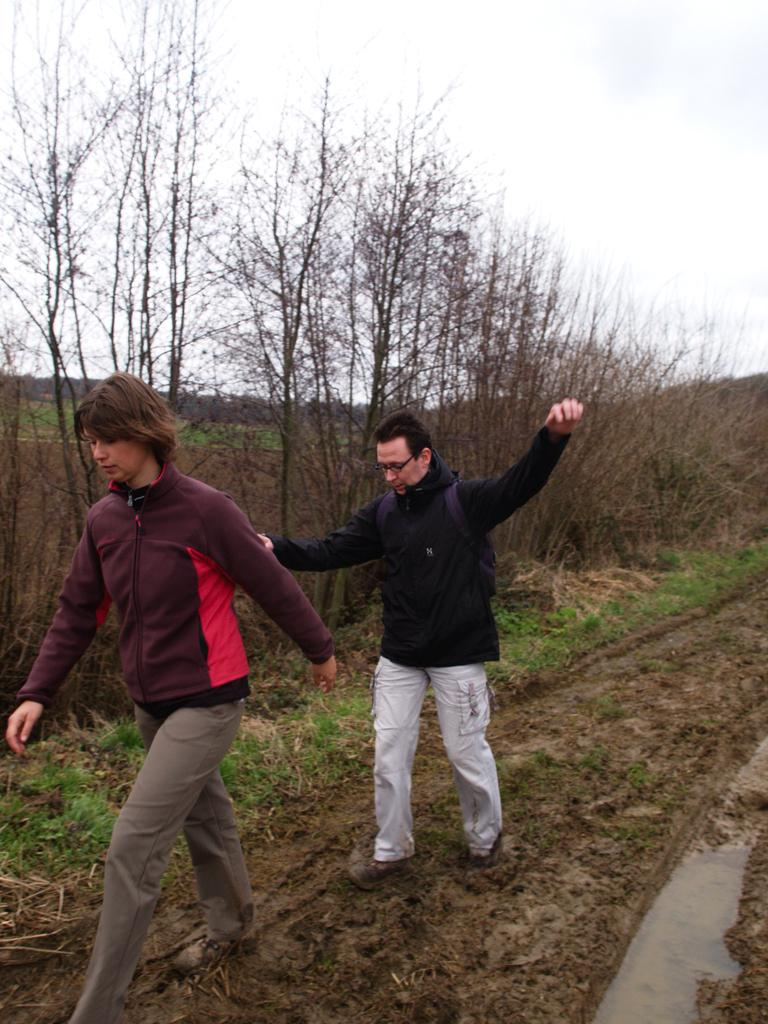What are the two people in the image doing? The two people in the image are walking. How can you differentiate the two people? The people are wearing different color dresses. What can be seen in the background of the image? There are dry trees and grass visible in the background. What is the color of the sky in the image? The sky is blue and white in color. Where is the lunchroom located in the image? There is no lunchroom present in the image. What type of zinc is used to create the dry trees in the image? The image does not depict the creation process of the dry trees, and there is no mention of zinc being used. 